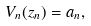Convert formula to latex. <formula><loc_0><loc_0><loc_500><loc_500>V _ { n } ( z _ { n } ) = a _ { n } ,</formula> 